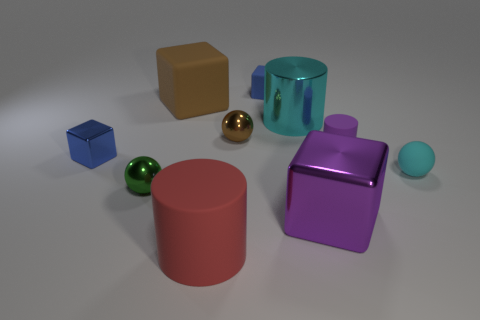Subtract all purple blocks. How many blocks are left? 3 Subtract all metallic spheres. How many spheres are left? 1 Subtract all cylinders. How many objects are left? 7 Subtract 1 balls. How many balls are left? 2 Subtract all cyan cylinders. How many yellow spheres are left? 0 Subtract all green rubber cylinders. Subtract all metal blocks. How many objects are left? 8 Add 6 purple metal cubes. How many purple metal cubes are left? 7 Add 9 blue rubber cubes. How many blue rubber cubes exist? 10 Subtract 1 red cylinders. How many objects are left? 9 Subtract all yellow balls. Subtract all brown cubes. How many balls are left? 3 